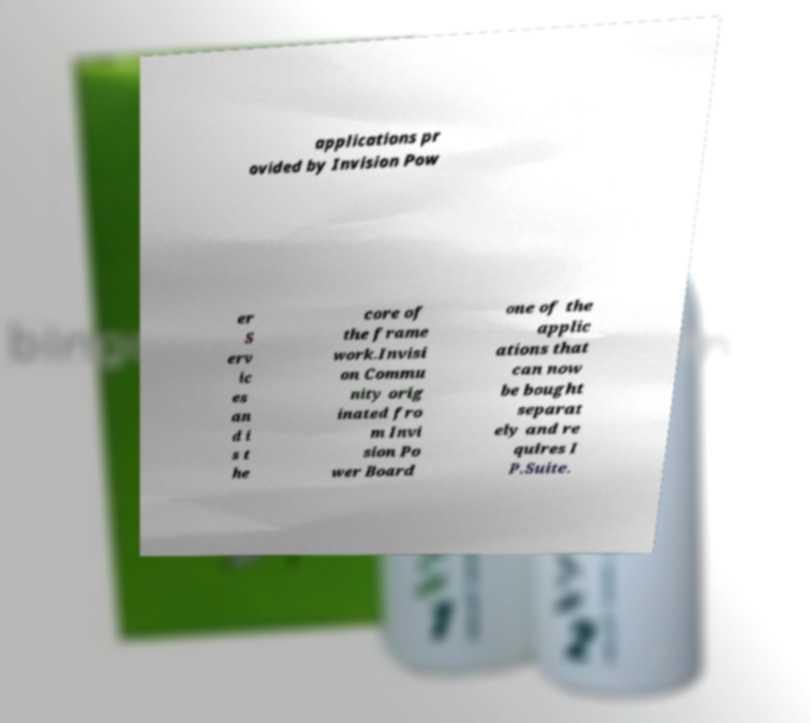Could you assist in decoding the text presented in this image and type it out clearly? applications pr ovided by Invision Pow er S erv ic es an d i s t he core of the frame work.Invisi on Commu nity orig inated fro m Invi sion Po wer Board one of the applic ations that can now be bought separat ely and re quires I P.Suite. 